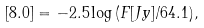<formula> <loc_0><loc_0><loc_500><loc_500>[ 8 . 0 ] = - 2 . 5 \log \, ( F [ J y ] / 6 4 . 1 ) ,</formula> 